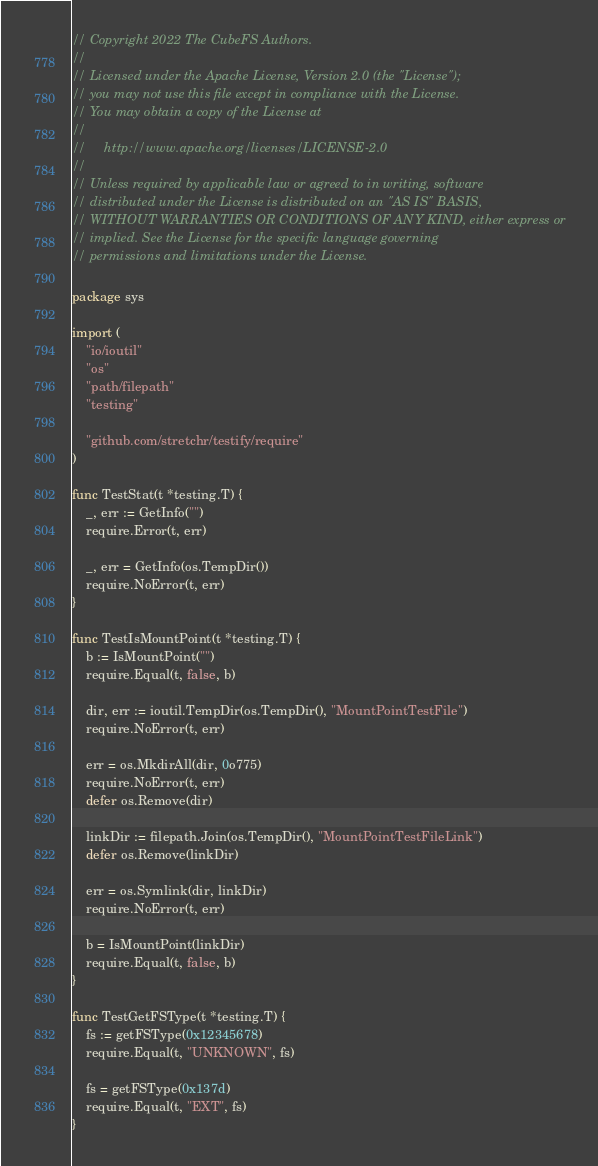<code> <loc_0><loc_0><loc_500><loc_500><_Go_>// Copyright 2022 The CubeFS Authors.
//
// Licensed under the Apache License, Version 2.0 (the "License");
// you may not use this file except in compliance with the License.
// You may obtain a copy of the License at
//
//     http://www.apache.org/licenses/LICENSE-2.0
//
// Unless required by applicable law or agreed to in writing, software
// distributed under the License is distributed on an "AS IS" BASIS,
// WITHOUT WARRANTIES OR CONDITIONS OF ANY KIND, either express or
// implied. See the License for the specific language governing
// permissions and limitations under the License.

package sys

import (
	"io/ioutil"
	"os"
	"path/filepath"
	"testing"

	"github.com/stretchr/testify/require"
)

func TestStat(t *testing.T) {
	_, err := GetInfo("")
	require.Error(t, err)

	_, err = GetInfo(os.TempDir())
	require.NoError(t, err)
}

func TestIsMountPoint(t *testing.T) {
	b := IsMountPoint("")
	require.Equal(t, false, b)

	dir, err := ioutil.TempDir(os.TempDir(), "MountPointTestFile")
	require.NoError(t, err)

	err = os.MkdirAll(dir, 0o775)
	require.NoError(t, err)
	defer os.Remove(dir)

	linkDir := filepath.Join(os.TempDir(), "MountPointTestFileLink")
	defer os.Remove(linkDir)

	err = os.Symlink(dir, linkDir)
	require.NoError(t, err)

	b = IsMountPoint(linkDir)
	require.Equal(t, false, b)
}

func TestGetFSType(t *testing.T) {
	fs := getFSType(0x12345678)
	require.Equal(t, "UNKNOWN", fs)

	fs = getFSType(0x137d)
	require.Equal(t, "EXT", fs)
}
</code> 